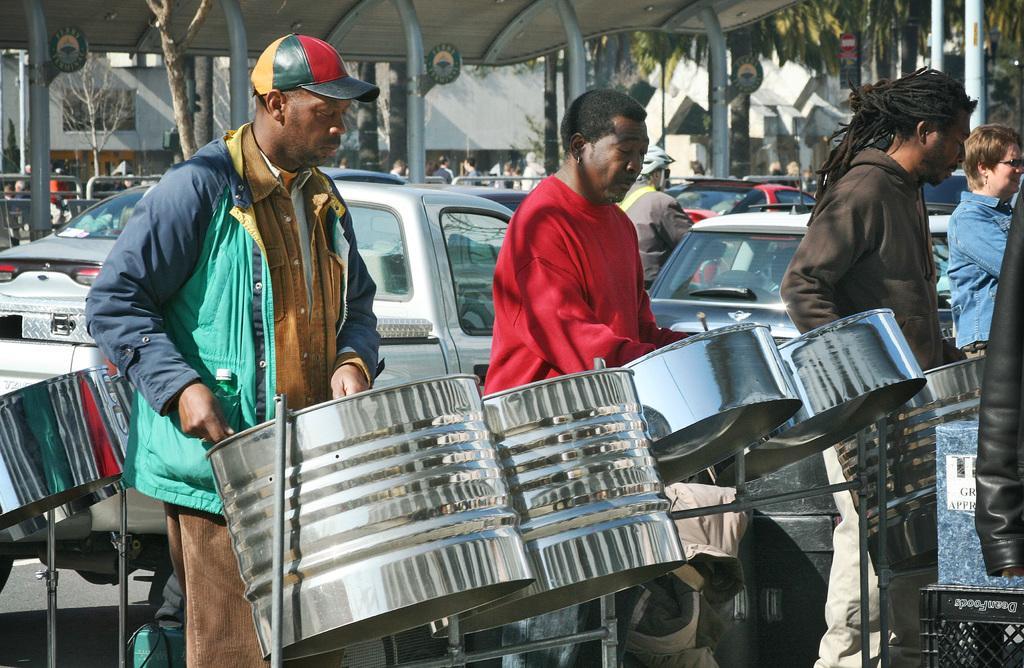Please provide a concise description of this image. In this image there are a few people playing drums in front of them, behind them there are cars parked, on the other side of the cars there are pillars, metal rod fence, on the other side of the fence there are a few people walking, in the background of the image there are trees and buildings and on the metal rods there are some display boards. 